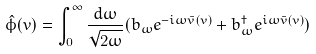Convert formula to latex. <formula><loc_0><loc_0><loc_500><loc_500>\hat { \phi } ( v ) = \int _ { 0 } ^ { \infty } \frac { d \omega } { \sqrt { 2 \omega } } ( b _ { \omega } e ^ { - i \omega \bar { v } ( v ) } + b ^ { \dagger } _ { \omega } e ^ { i \omega \bar { v } ( v ) } )</formula> 